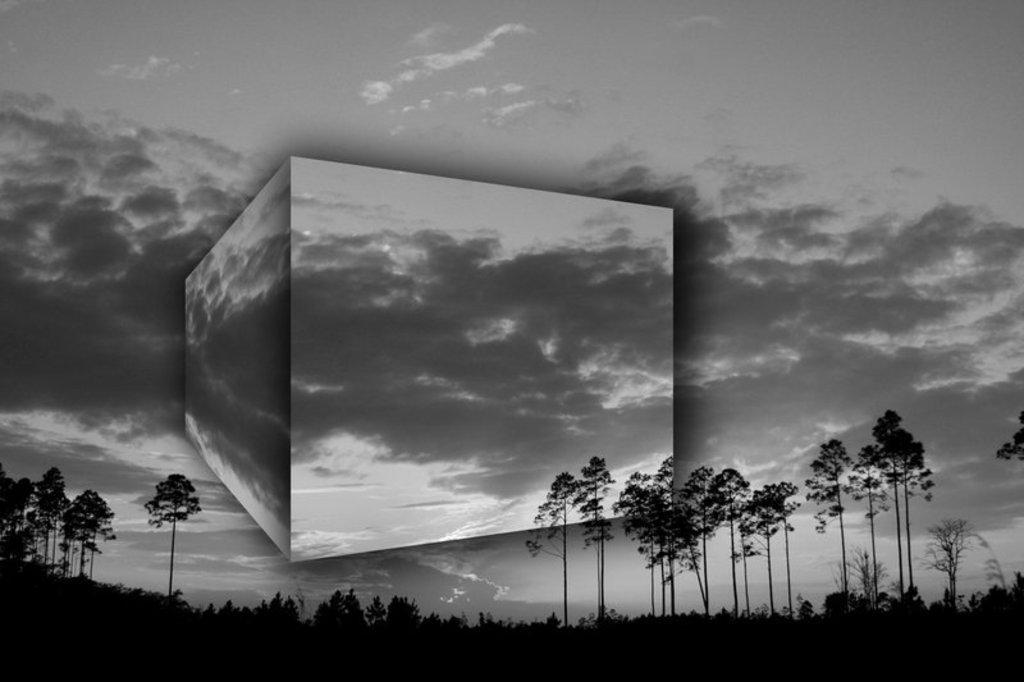Describe this image in one or two sentences. In this picture I can see there are plants, trees and the sky is clear. 